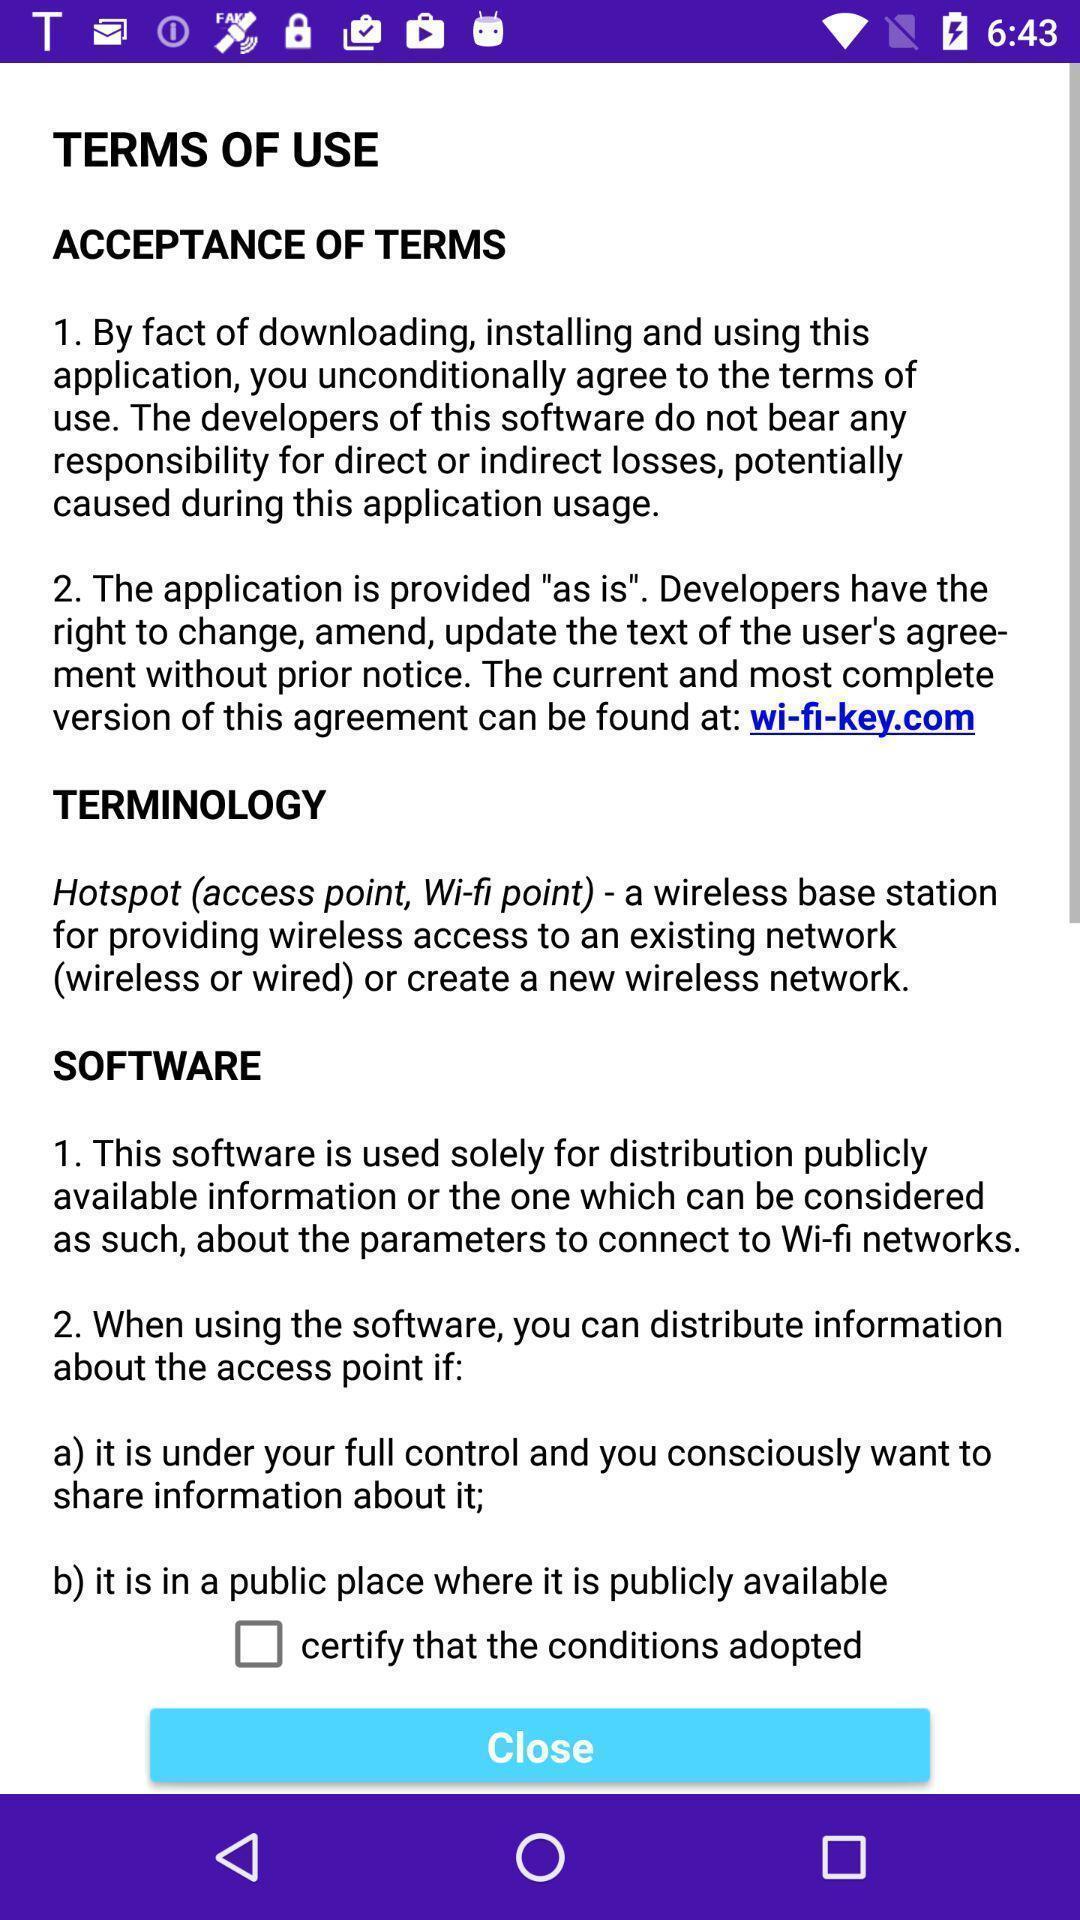Describe this image in words. Page showing details of terms of use on an app. 